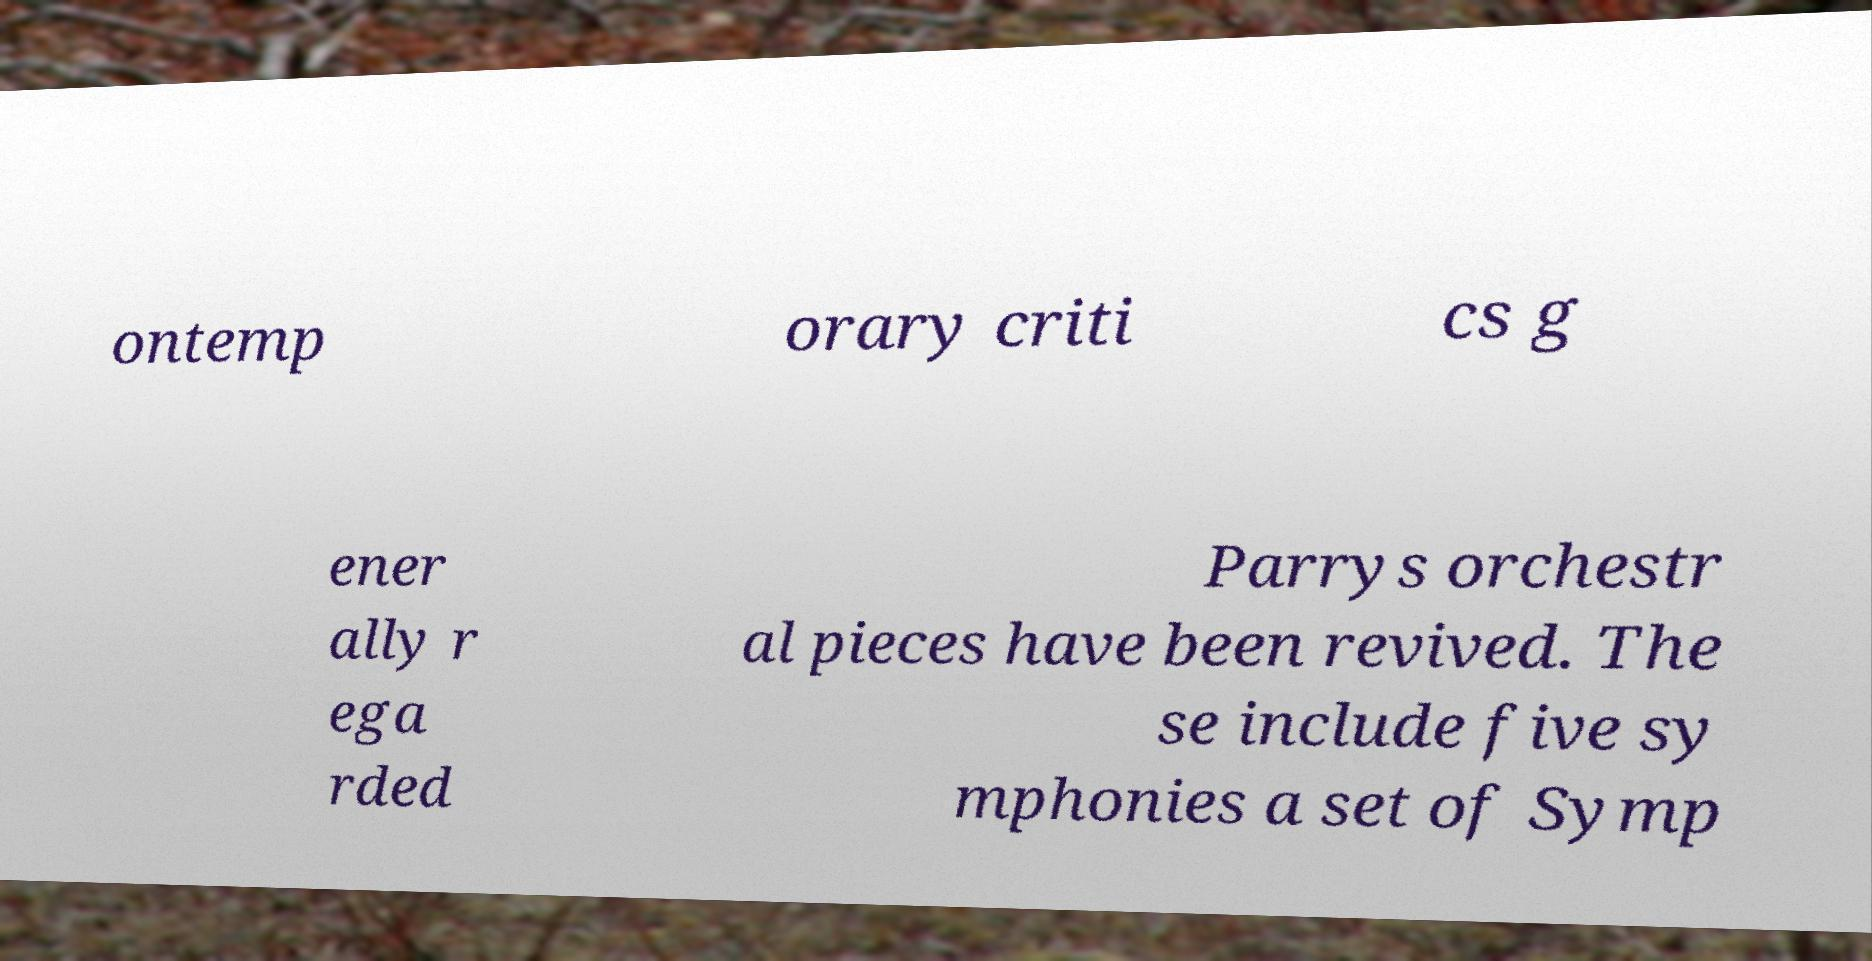Can you read and provide the text displayed in the image?This photo seems to have some interesting text. Can you extract and type it out for me? ontemp orary criti cs g ener ally r ega rded Parrys orchestr al pieces have been revived. The se include five sy mphonies a set of Symp 